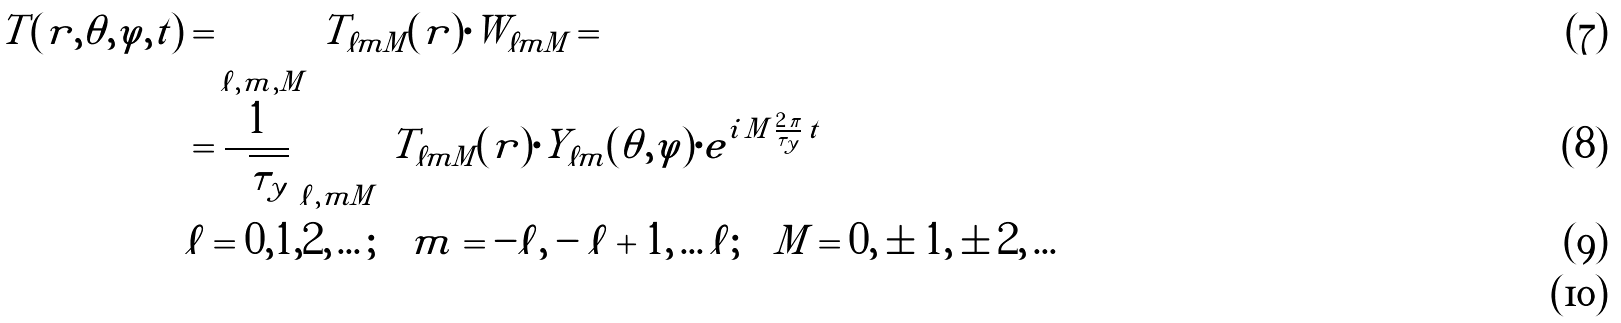Convert formula to latex. <formula><loc_0><loc_0><loc_500><loc_500>T ( r , \theta , \varphi , t ) & = \sum _ { \ell , m , M } \, T _ { \ell m M } ( r ) \cdot W _ { \ell m M } = \\ & = \frac { 1 } { \sqrt { \tau _ { y } } } \, \sum _ { \ell , m M } \, T _ { \ell m M } ( r ) \cdot Y _ { \ell m } ( \theta , \varphi ) \cdot e ^ { i \, M \, \frac { 2 \, \pi } { \tau _ { y } } \, t } \\ & \ell = 0 , 1 , 2 , \dots ; \quad m = - \ell , - \ell + 1 , \dots \ell ; \quad M = 0 , \pm 1 , \pm 2 , \dots \\</formula> 